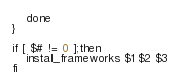<code> <loc_0><loc_0><loc_500><loc_500><_Bash_>    done
}

if [ $# != 0 ];then
	install_frameworks $1 $2 $3
fi
</code> 